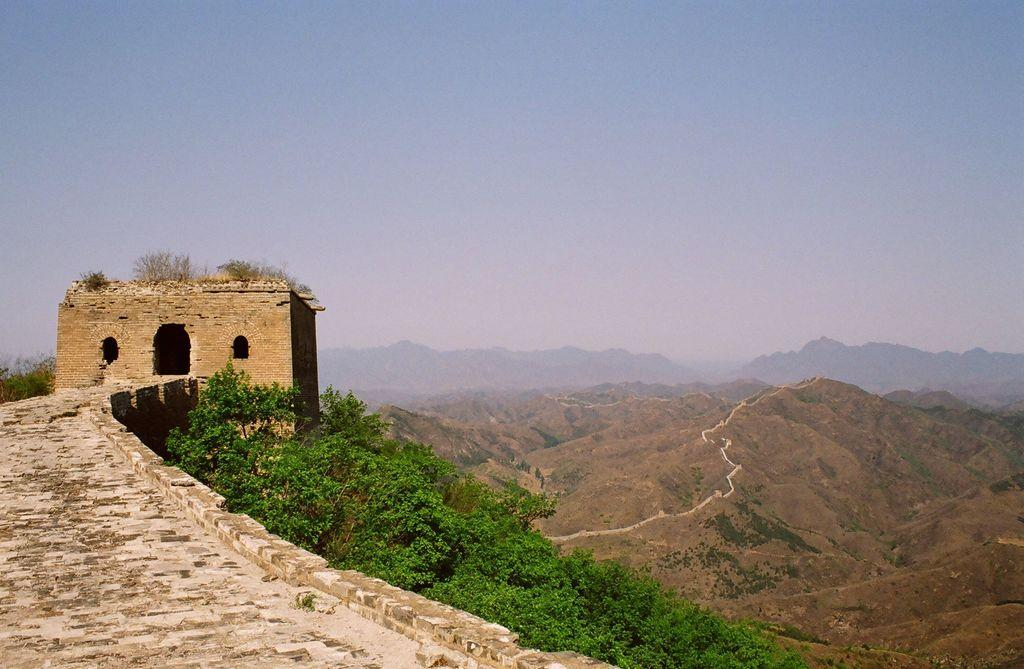What structure is located on the left side of the image? There is a fort on the left side of the image. What pathway can be seen in the image? There is a walkway in the image. What type of natural features are visible in the background of the image? There are trees and hills in the background of the image. What is visible at the top of the image? The sky is visible in the background of the image. How much rice is present on the walkway in the image? There is no rice present on the walkway in the image. What mark can be seen on the trees in the background of the image? There are no marks visible on the trees in the background of the image. 